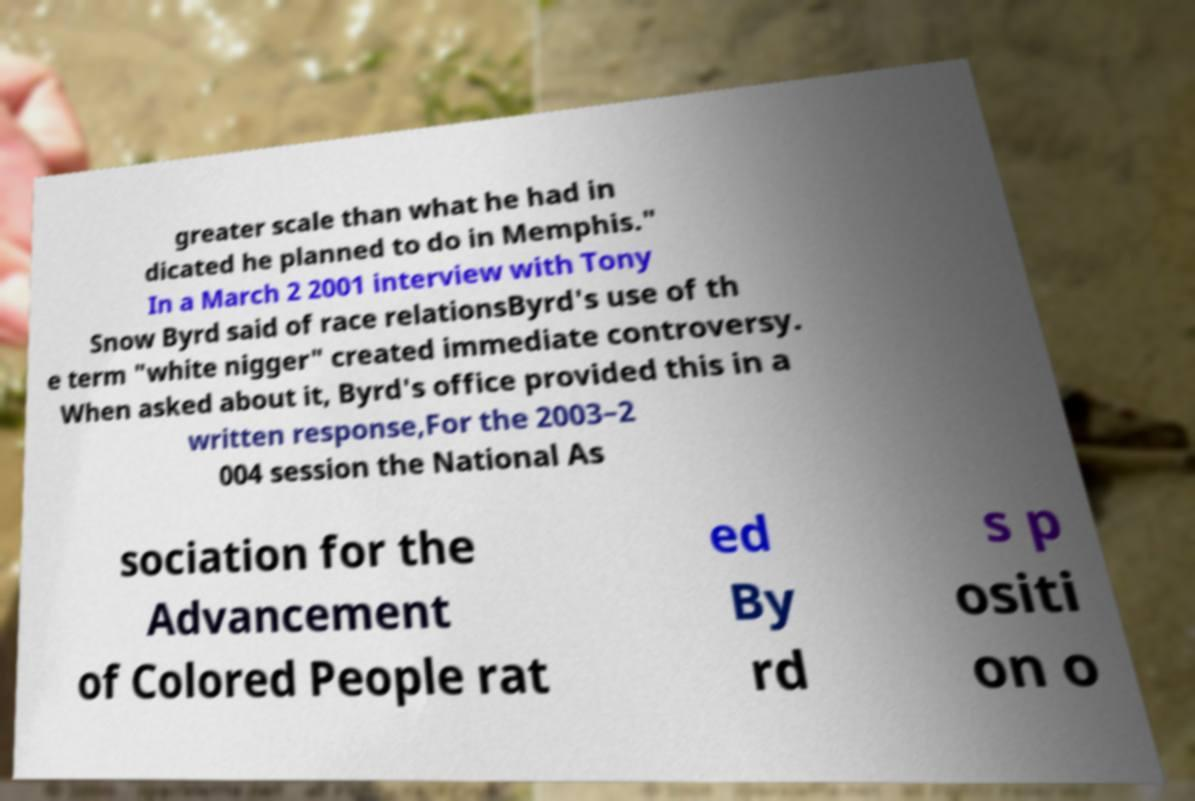Please identify and transcribe the text found in this image. greater scale than what he had in dicated he planned to do in Memphis." In a March 2 2001 interview with Tony Snow Byrd said of race relationsByrd's use of th e term "white nigger" created immediate controversy. When asked about it, Byrd's office provided this in a written response,For the 2003–2 004 session the National As sociation for the Advancement of Colored People rat ed By rd s p ositi on o 